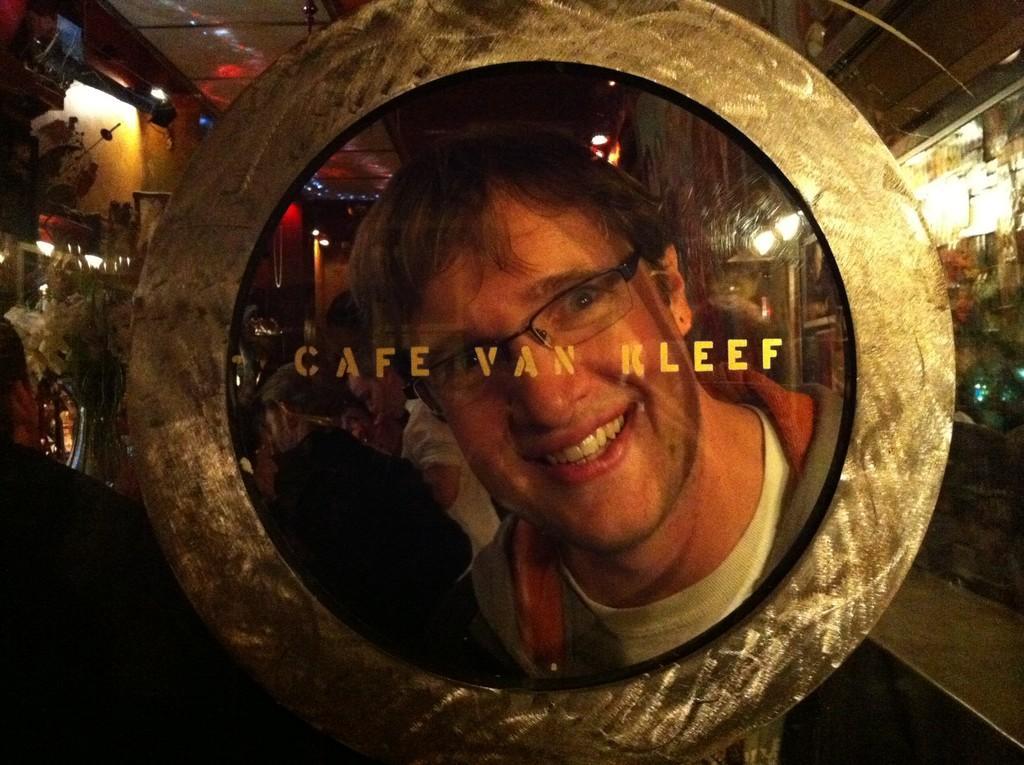Describe this image in one or two sentences. This is the picture of inner view of a room which looks like a cafe and there are some people. We can see an object with text and there is a reflection of a person on the object. we can see objects like flower vase and some other things in the background. 